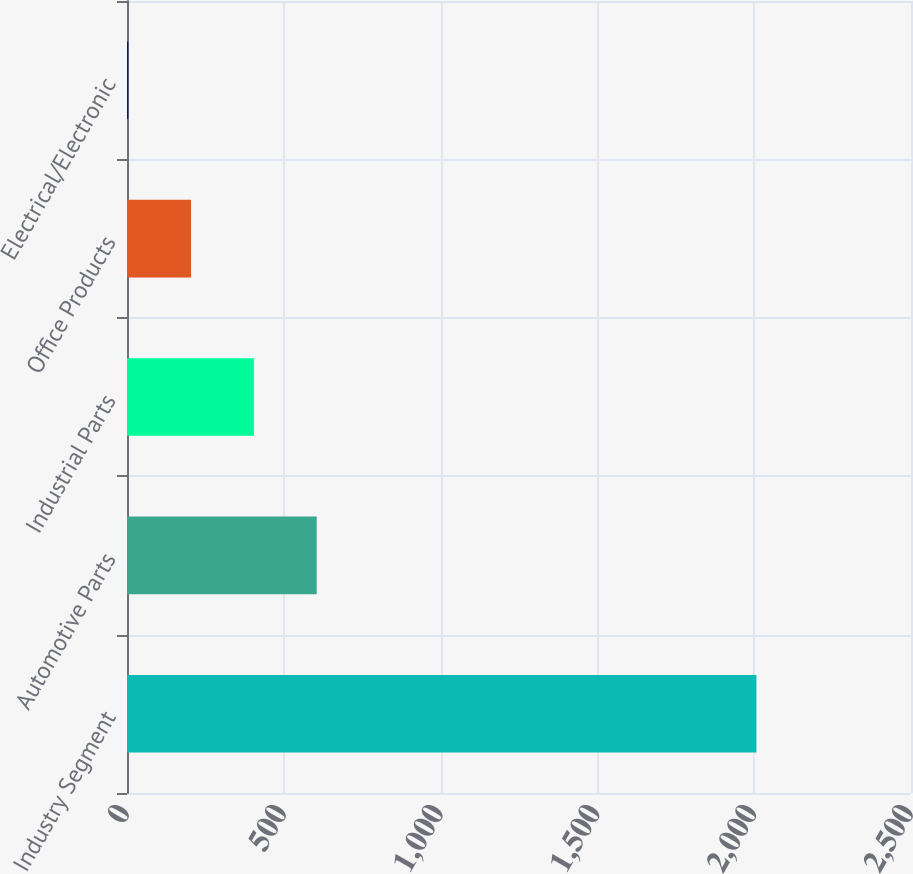Convert chart. <chart><loc_0><loc_0><loc_500><loc_500><bar_chart><fcel>Industry Segment<fcel>Automotive Parts<fcel>Industrial Parts<fcel>Office Products<fcel>Electrical/Electronic<nl><fcel>2007<fcel>604.9<fcel>404.6<fcel>204.3<fcel>4<nl></chart> 